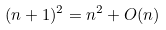<formula> <loc_0><loc_0><loc_500><loc_500>( n + 1 ) ^ { 2 } = n ^ { 2 } + O ( n )</formula> 